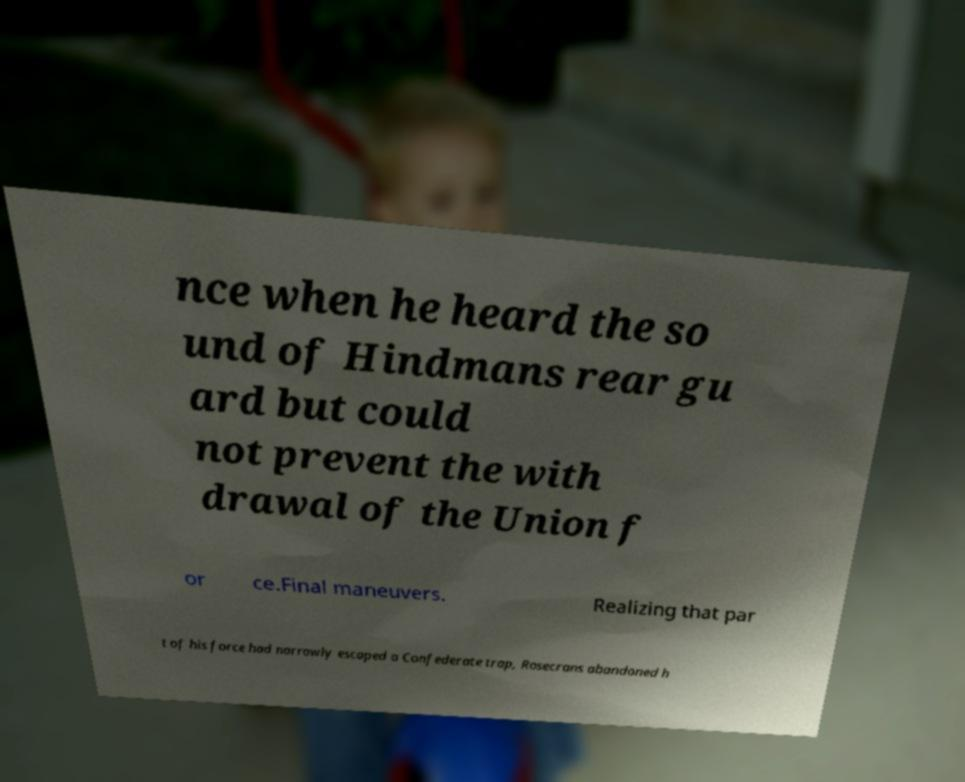Please identify and transcribe the text found in this image. nce when he heard the so und of Hindmans rear gu ard but could not prevent the with drawal of the Union f or ce.Final maneuvers. Realizing that par t of his force had narrowly escaped a Confederate trap, Rosecrans abandoned h 